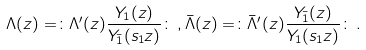<formula> <loc_0><loc_0><loc_500><loc_500>\Lambda ( z ) = \colon \Lambda ^ { \prime } ( z ) \frac { Y _ { 1 } ( z ) } { Y _ { \bar { 1 } } ( s _ { 1 } z ) } \colon \, , \bar { \Lambda } ( z ) = \colon \bar { \Lambda } ^ { \prime } ( z ) \frac { Y _ { \bar { 1 } } ( z ) } { Y _ { 1 } ( s _ { 1 } z ) } \colon \, .</formula> 